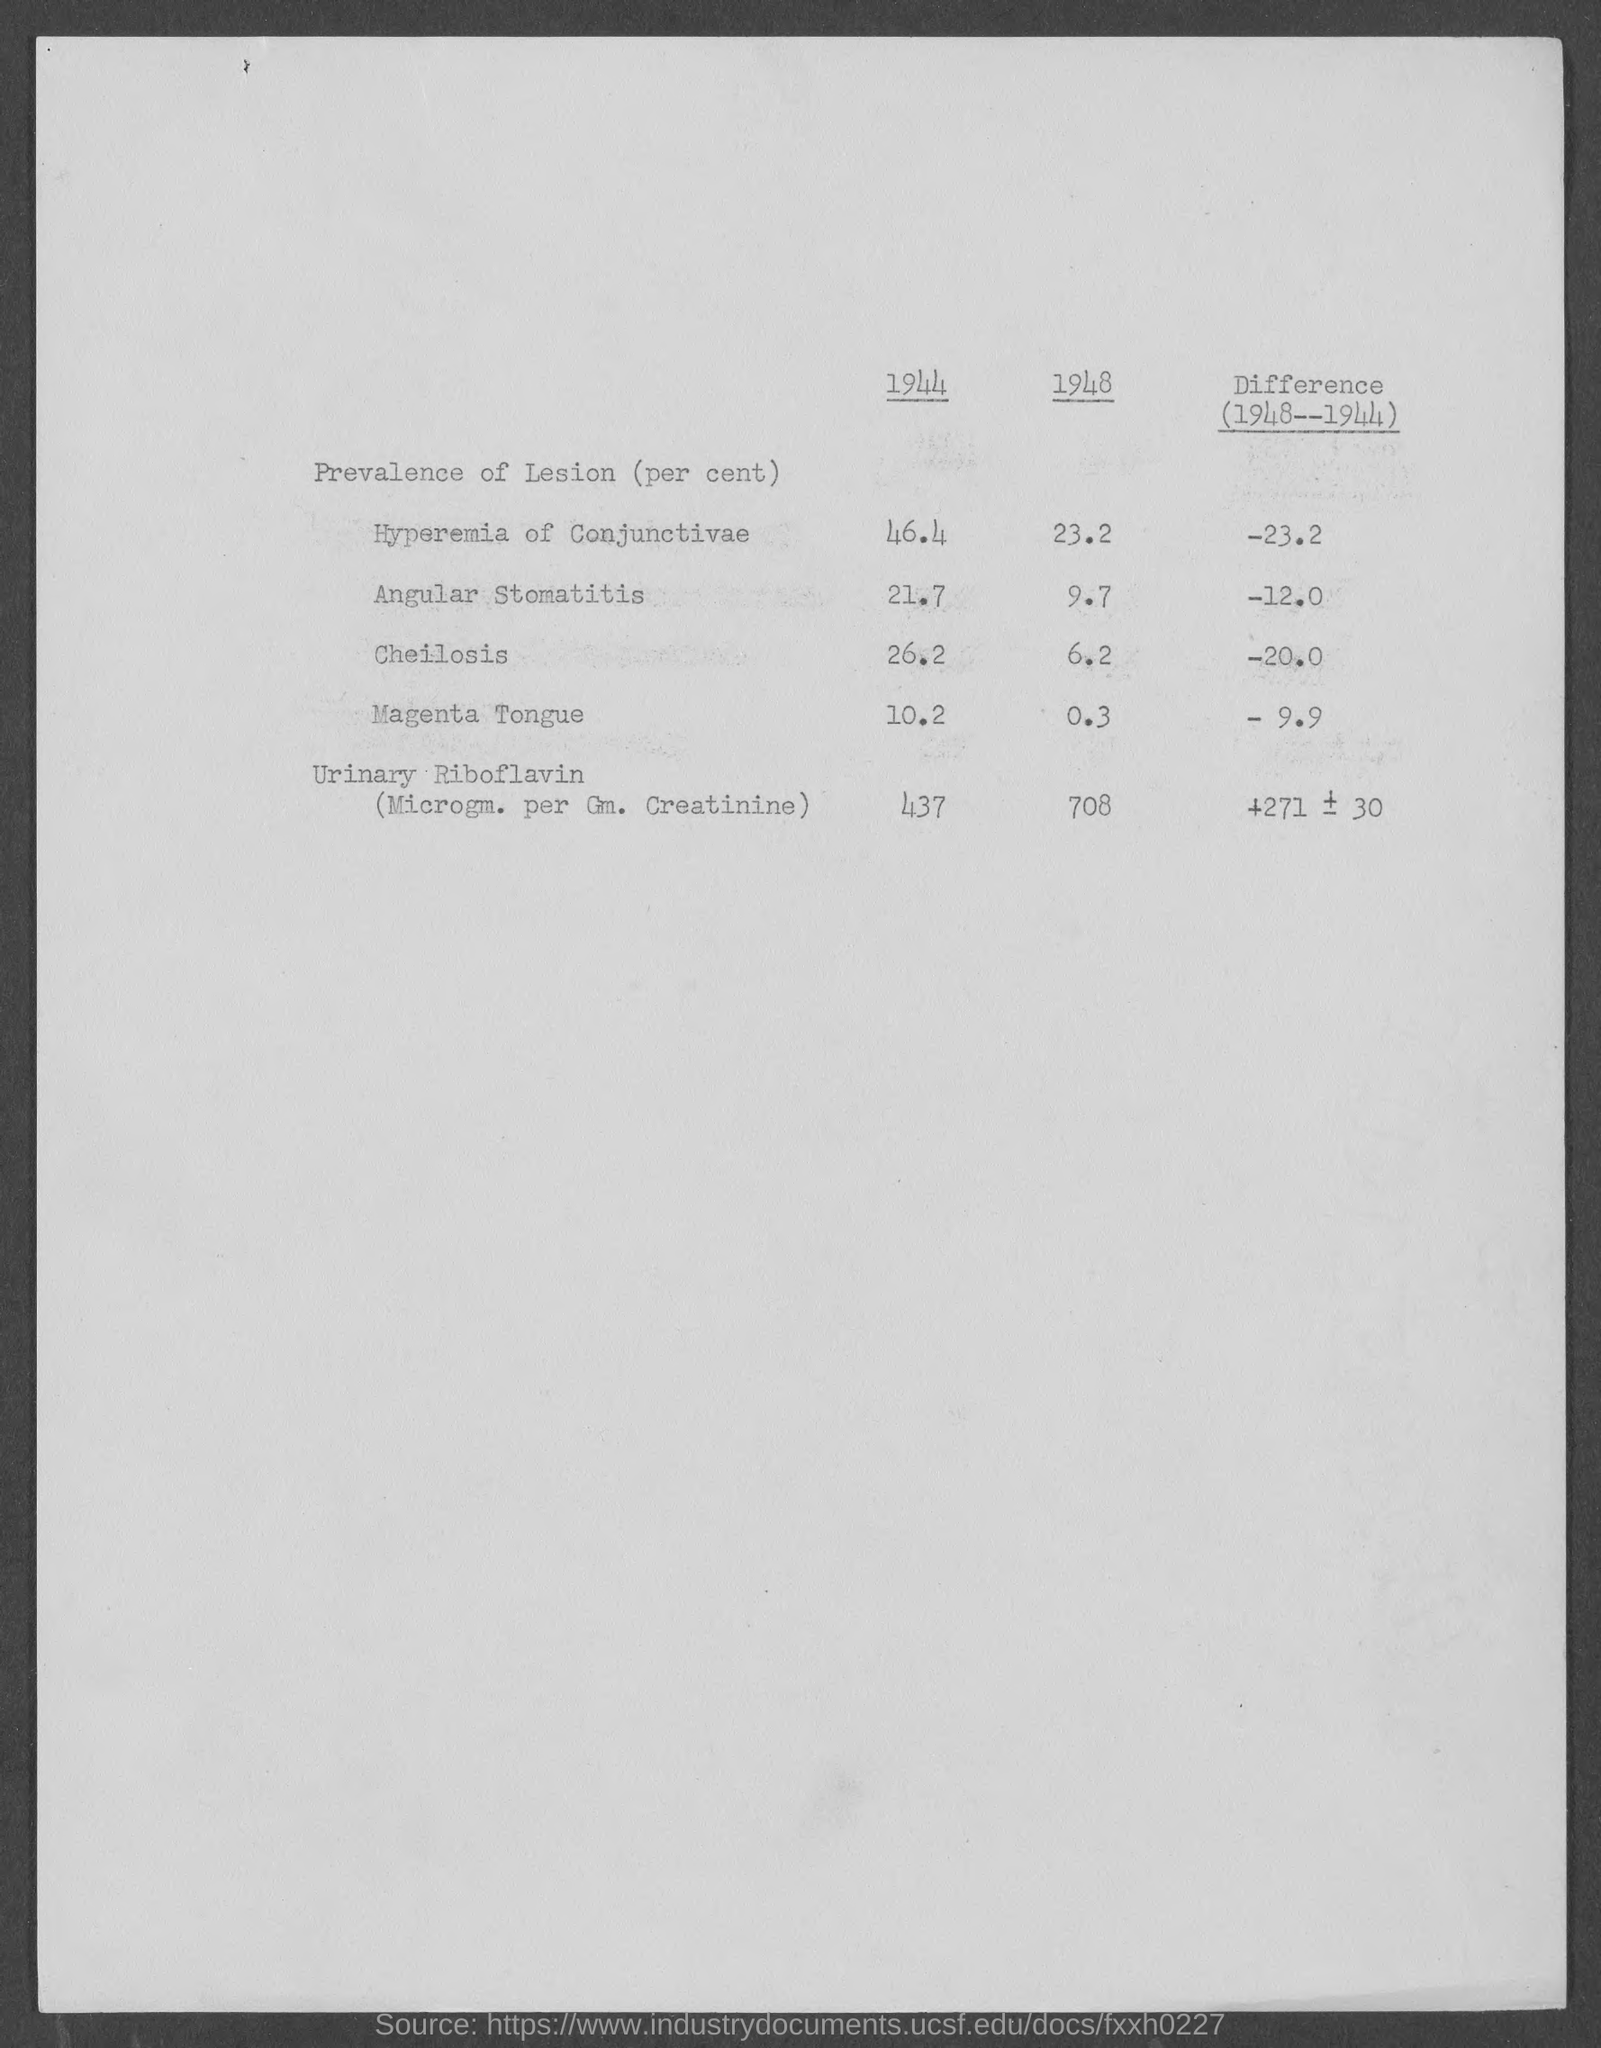What percent is the prevalence of lesion in Hyperemia of Conjunctivae in the year 1944?
Provide a short and direct response. 46.4. What percent is the prevalence of lesion in Magenta Tongue in the year 1944?
Give a very brief answer. 10.2. What percent is the prevalence of lesion in Cheilosis in the year 1948?
Provide a short and direct response. 6.2. 